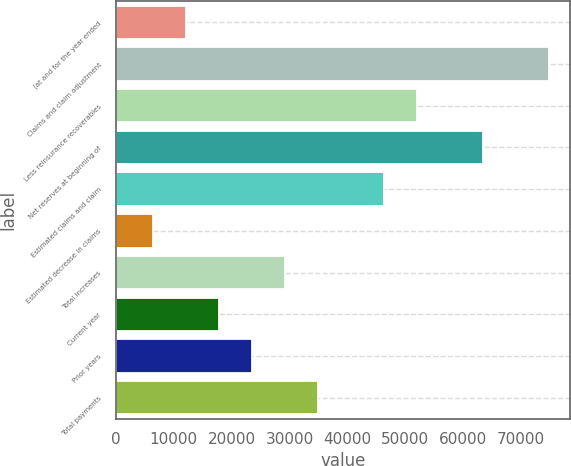<chart> <loc_0><loc_0><loc_500><loc_500><bar_chart><fcel>(at and for the year ended<fcel>Claims and claim adjustment<fcel>Less reinsurance recoverables<fcel>Net reserves at beginning of<fcel>Estimated claims and claim<fcel>Estimated decrease in claims<fcel>Total increases<fcel>Current year<fcel>Prior years<fcel>Total payments<nl><fcel>12050.2<fcel>74707.3<fcel>51922.9<fcel>63315.1<fcel>46226.8<fcel>6354.1<fcel>29138.5<fcel>17746.3<fcel>23442.4<fcel>34834.6<nl></chart> 